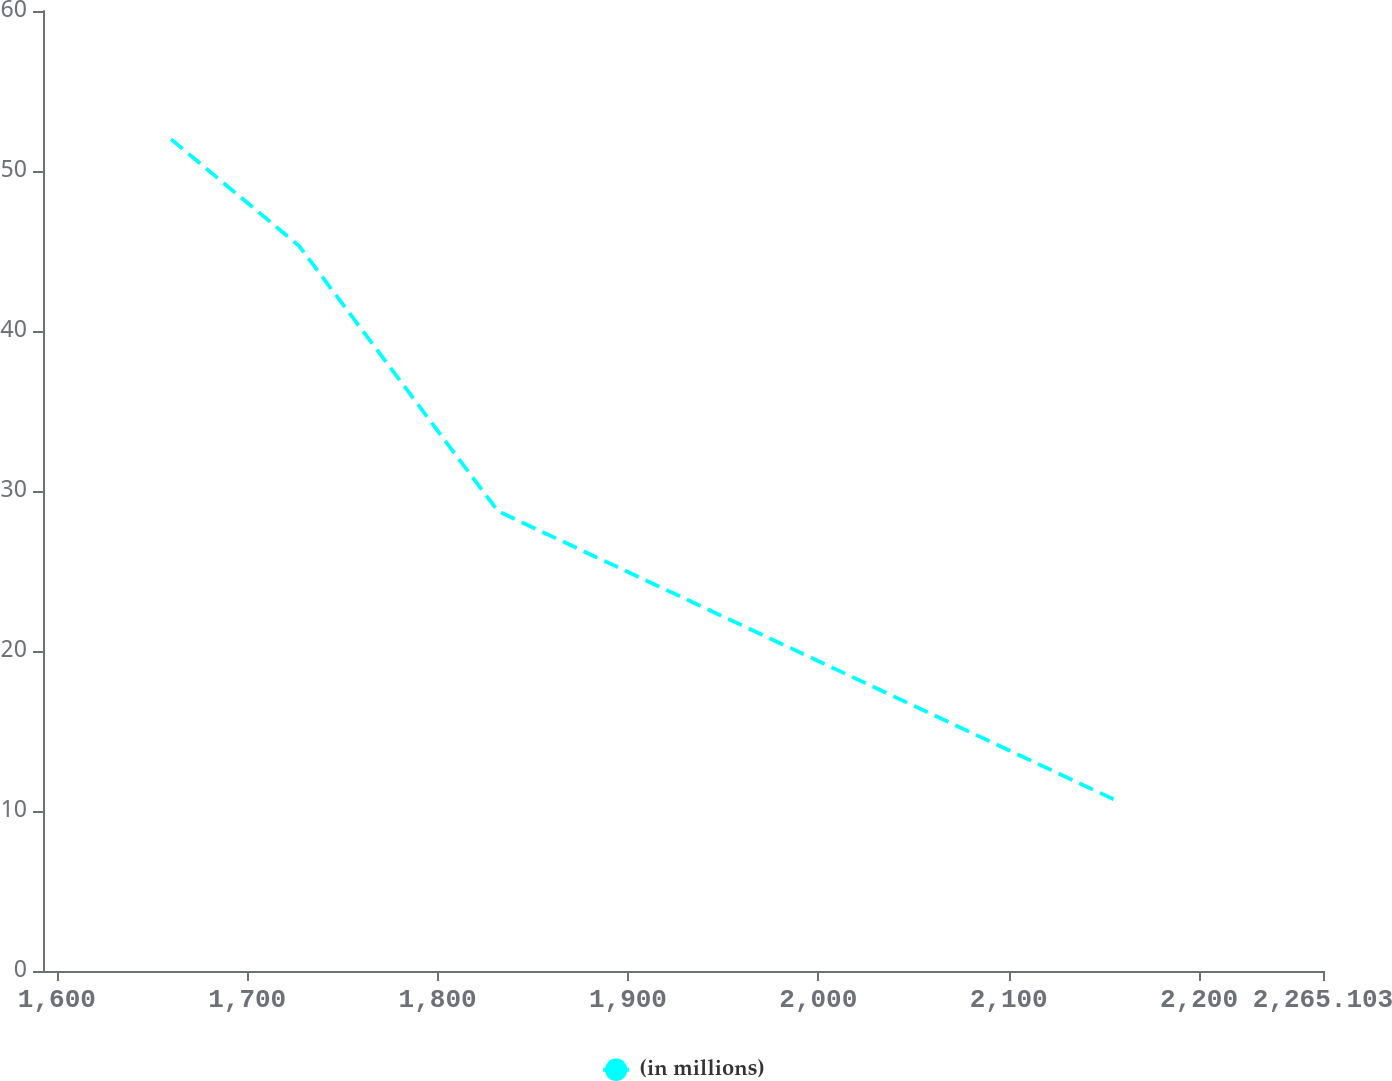Convert chart. <chart><loc_0><loc_0><loc_500><loc_500><line_chart><ecel><fcel>(in millions)<nl><fcel>1659.97<fcel>51.99<nl><fcel>1727.21<fcel>45.32<nl><fcel>1831.72<fcel>28.74<nl><fcel>2158.38<fcel>10.55<nl><fcel>2332.34<fcel>4.11<nl></chart> 